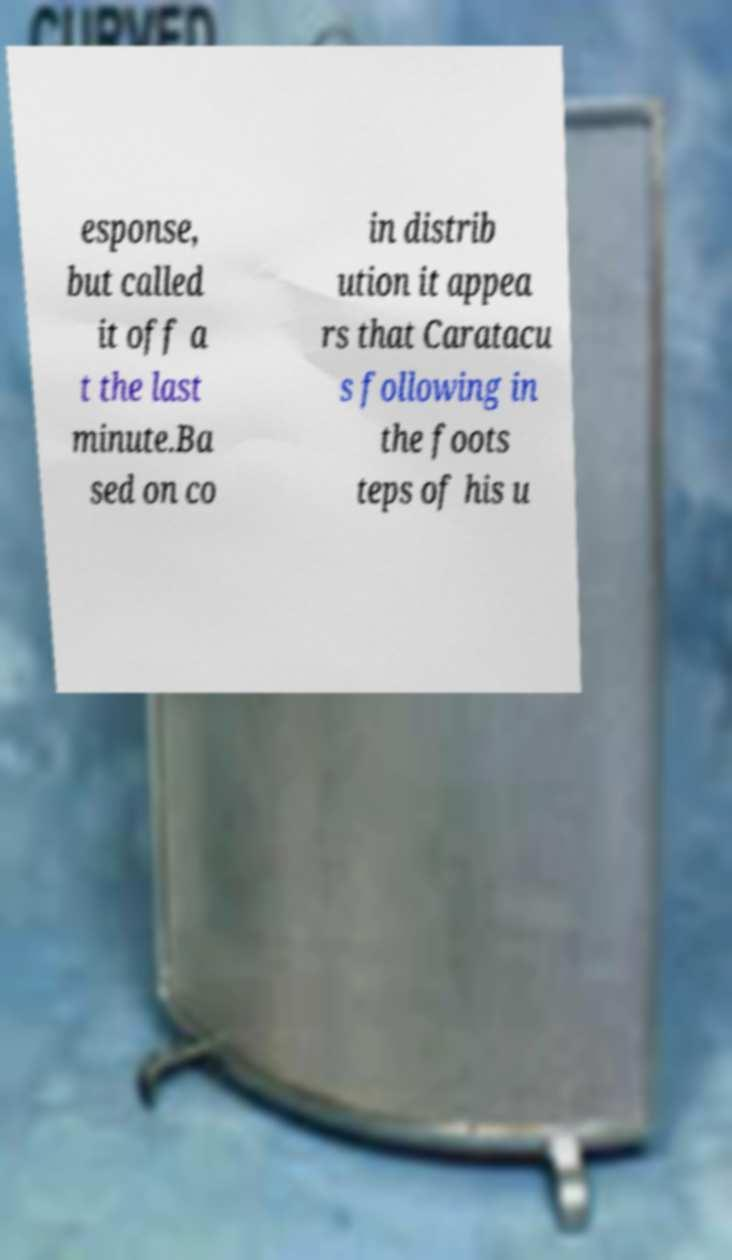For documentation purposes, I need the text within this image transcribed. Could you provide that? esponse, but called it off a t the last minute.Ba sed on co in distrib ution it appea rs that Caratacu s following in the foots teps of his u 